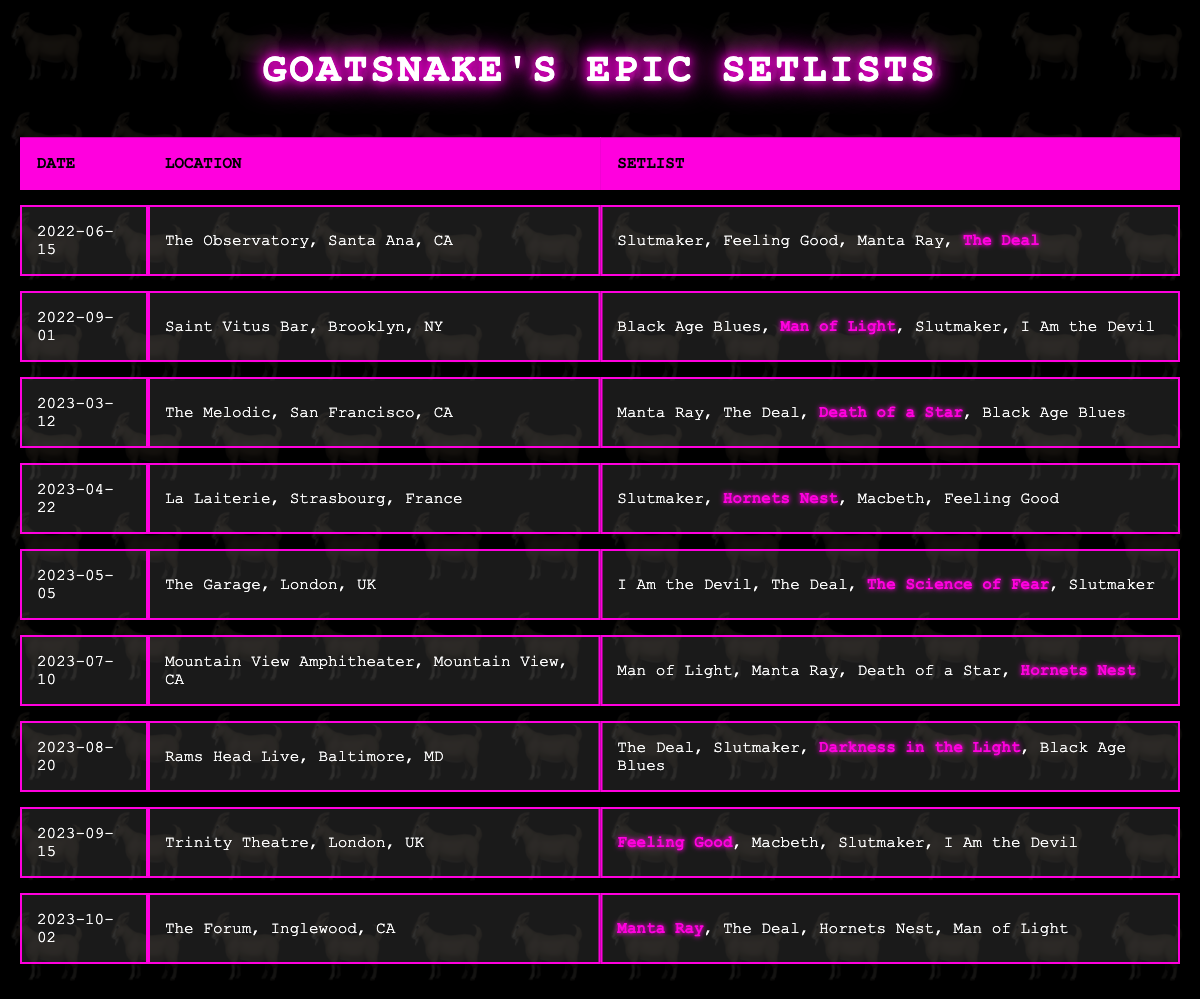What's the most recent concert date from the table? The last date listed in the table is "2023-10-02," which indicates the most recent concert.
Answer: 2023-10-02 How many concerts featured the song "Slutmaker" in their setlist? Counting the rows in the table, "Slutmaker" appears in the setlist of 6 concerts.
Answer: 6 Which song was highlighted in the concert on 2023-09-15? The highlighted song for that date is "Feeling Good," as indicated in the corresponding row of the table.
Answer: Feeling Good Did the concert on 2023-07-10 include "I Am the Devil" in its setlist? Checking the setlist for that date, "I Am the Devil" is not present, confirming a "no" answer.
Answer: No Which two concerts featured "Hornets Nest"? The concerts on 2023-04-22 and 2023-07-10 highlighted "Hornets Nest" in their setlists, showing the selected concerts.
Answer: 2023-04-22 and 2023-07-10 What's the total number of unique songs performed across all concerts? The unique songs based on the setlists are: Slutmaker, Feeling Good, Manta Ray, The Deal, Black Age Blues, Man of Light, I Am the Devil, Death of a Star, Hornets Nest, The Science of Fear, and Darkness in the Light. This totals to 11 unique songs.
Answer: 11 What is the average number of songs listed per concert? Each concert has 4 songs in its setlist, and with 10 concerts, the total songs is 40. Therefore, the average is 40/10 = 4.
Answer: 4 Identify the concert with the earliest date and the highlighted song for that concert. The earliest date in the table is "2022-06-15," and the highlighted song for that concert is "The Deal."
Answer: 2022-06-15, The Deal Which two highlighted songs occurred more than once in the setlists? The songs "The Deal" and "Hornets Nest" both appeared more than once in the setlists, as seen when reviewing the highlighted entries in their respective concerts.
Answer: The Deal and Hornets Nest List the locations where "Death of a Star" was performed. "Death of a Star" was performed at two locations: The Melodic in San Francisco on 2023-03-12 and Mountain View Amphitheater in CA on 2023-07-10.
Answer: The Melodic, San Francisco and Mountain View Amphitheater, CA 